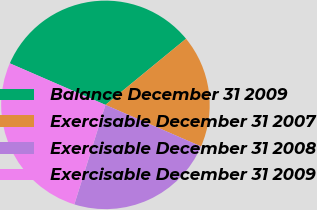<chart> <loc_0><loc_0><loc_500><loc_500><pie_chart><fcel>Balance December 31 2009<fcel>Exercisable December 31 2007<fcel>Exercisable December 31 2008<fcel>Exercisable December 31 2009<nl><fcel>32.54%<fcel>17.46%<fcel>23.29%<fcel>26.7%<nl></chart> 